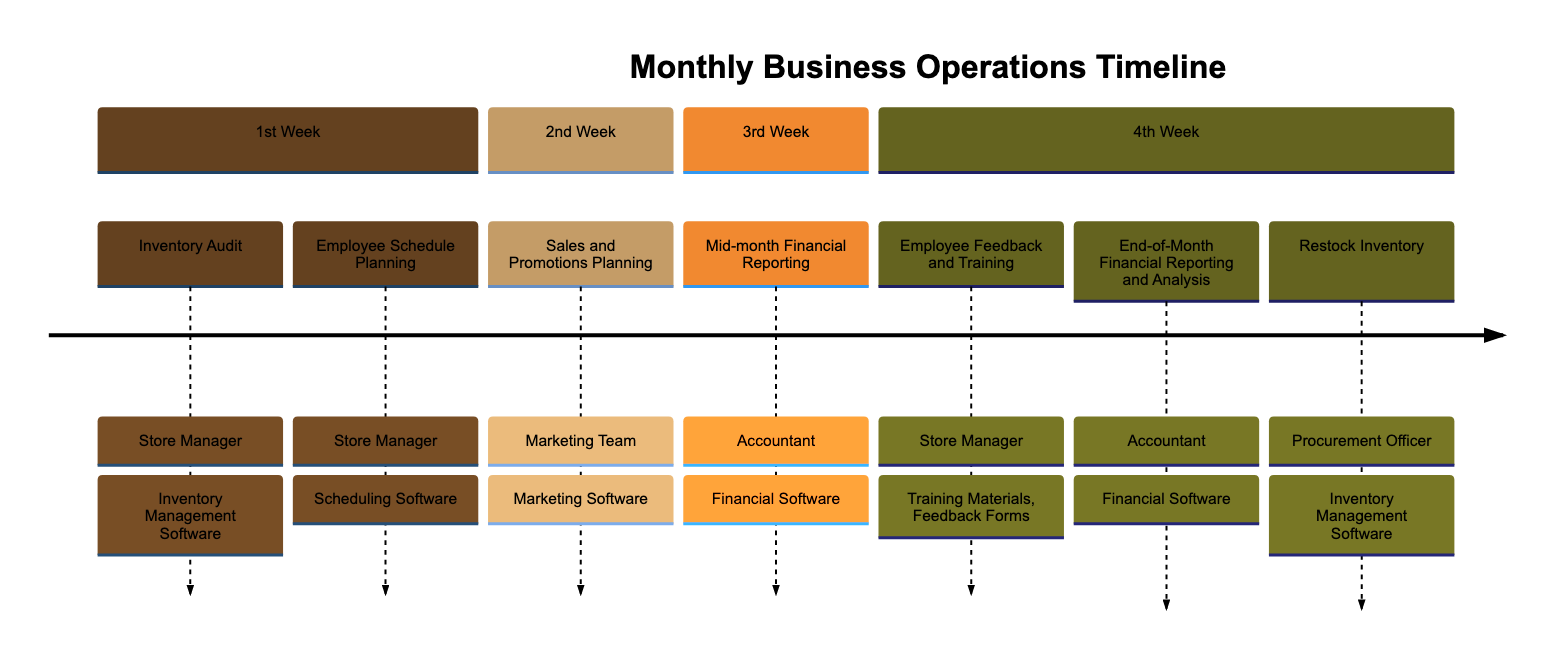What tasks are done in the 1st week? The diagram shows two tasks in the 1st week: "Inventory Audit" and "Employee Schedule Planning." These are listed under the section for the 1st week.
Answer: Inventory Audit, Employee Schedule Planning Who is responsible for the "End-of-Month Financial Reporting and Analysis"? By looking at the 4th week's tasks, the responsible party for "End-of-Month Financial Reporting and Analysis" is listed as "Accountant."
Answer: Accountant How many tasks are planned for the 2nd week? The diagram shows that there is one task listed in the 2nd week: "Sales and Promotions Planning." Thus, the total number of tasks for this week is 1.
Answer: 1 What tool is needed for "Restock Inventory"? In the 4th week of the timeline, under the task "Restock Inventory," the required tool is mentioned as "Inventory Management Software."
Answer: Inventory Management Software What is the frequency of financial reporting in this timeline? Financial reporting occurs twice within the timeline: once in the 3rd week (Mid-month Financial Reporting) and once in the 4th week (End-of-Month Financial Reporting and Analysis). This indicates a frequency of twice a month.
Answer: Twice What is the relationship between "Employee Schedule Planning" and the Store Manager? In the diagram, "Employee Schedule Planning" is a task that is specifically described as being the responsibility of the "Store Manager," indicating a direct connection between this task and the Store Manager.
Answer: Store Manager In which week does "Sales and Promotions Planning" occur? The task "Sales and Promotions Planning" is specifically listed under the 2nd week in the provided timeline details, making it clear that this planning occurs during that week.
Answer: 2nd week What kind of software is needed for "Mid-month Financial Reporting"? The diagram indicates that the "Mid-month Financial Reporting" task requires "Financial Software," which is directly mentioned next to it.
Answer: Financial Software How many different parties are responsible for tasks in the timeline? In total, there are three different parties mentioned: Store Manager, Marketing Team, and Accountant. This indicates a collaborative effort across these parties for the various tasks.
Answer: Three 